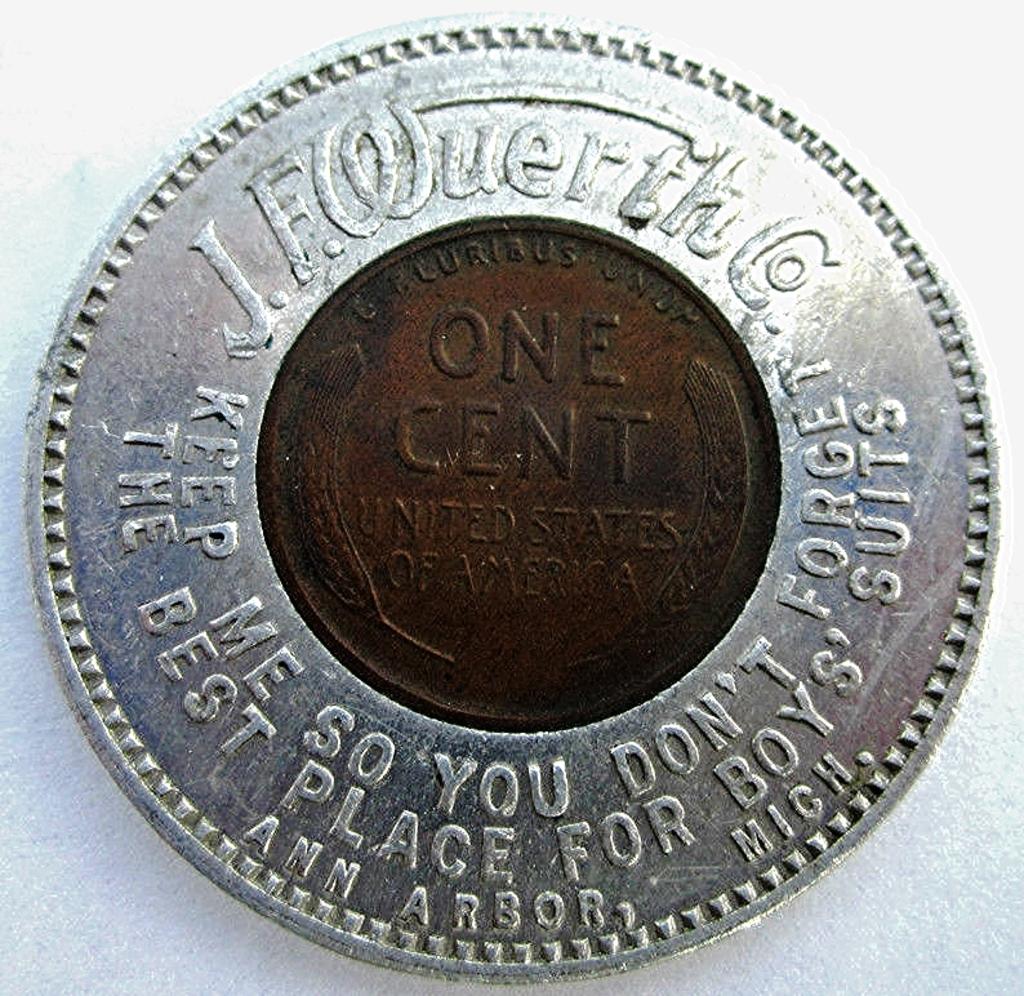What is the value of this coin?
Your answer should be compact. One cent. 